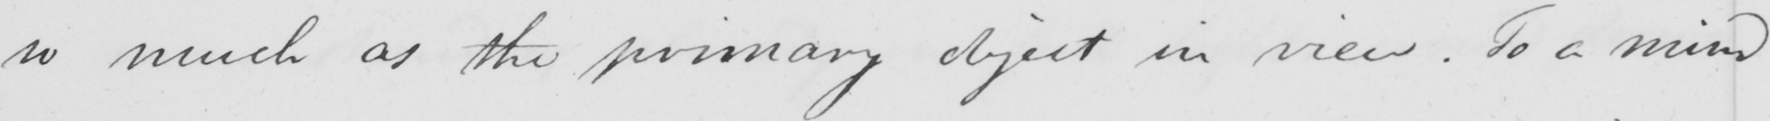What does this handwritten line say? so much as the primary object in view . To a mind 